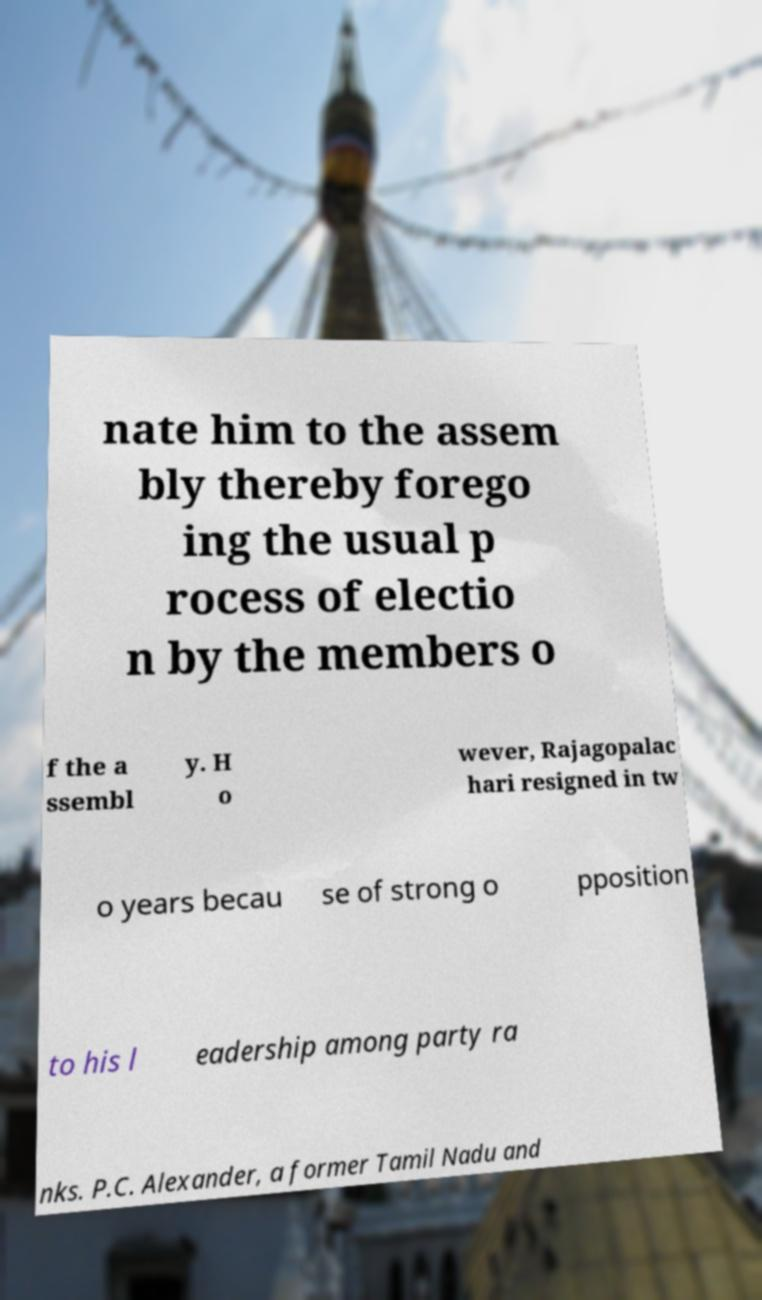Please identify and transcribe the text found in this image. nate him to the assem bly thereby forego ing the usual p rocess of electio n by the members o f the a ssembl y. H o wever, Rajagopalac hari resigned in tw o years becau se of strong o pposition to his l eadership among party ra nks. P.C. Alexander, a former Tamil Nadu and 